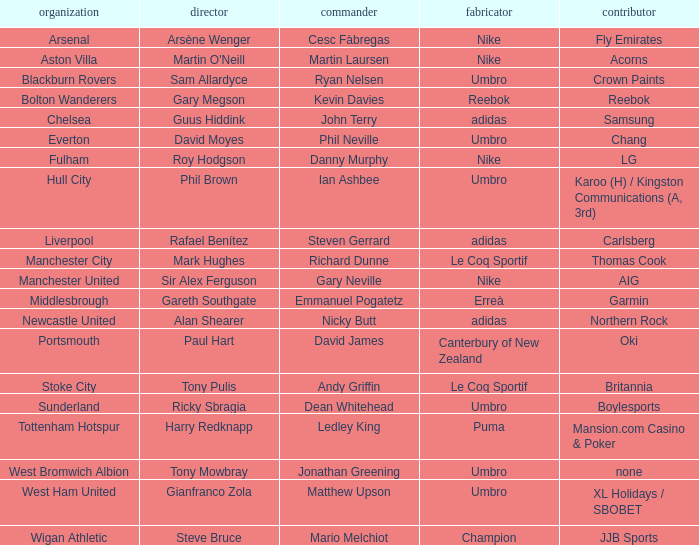In which club is Ledley King a captain? Tottenham Hotspur. 